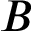Convert formula to latex. <formula><loc_0><loc_0><loc_500><loc_500>B</formula> 